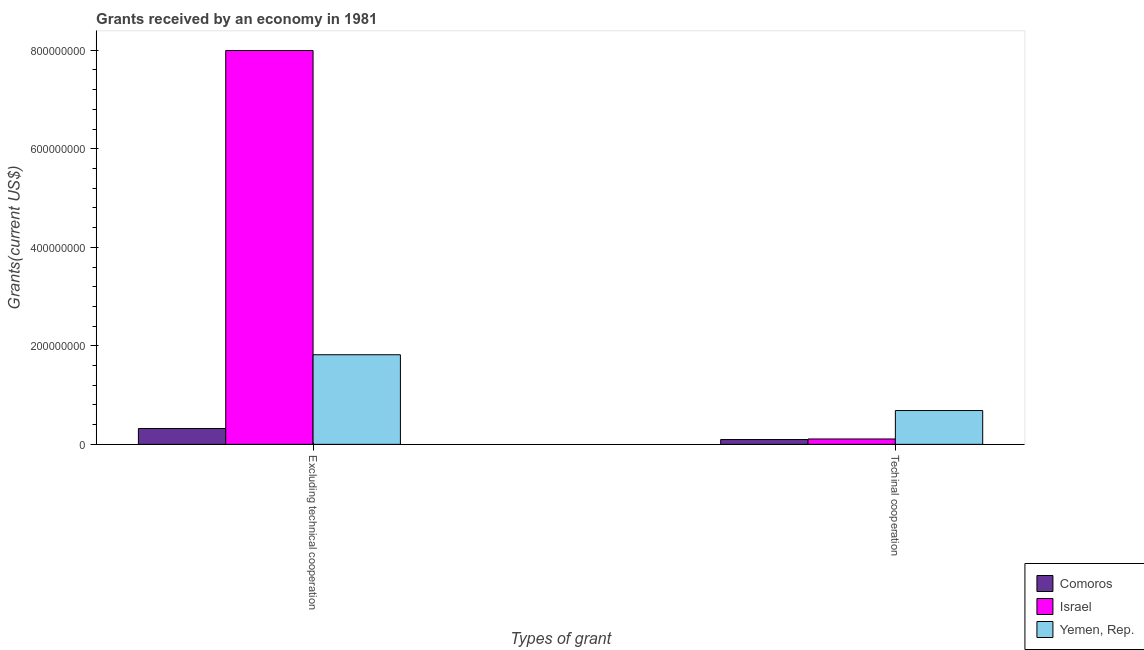How many different coloured bars are there?
Provide a succinct answer. 3. Are the number of bars on each tick of the X-axis equal?
Your answer should be very brief. Yes. How many bars are there on the 2nd tick from the left?
Provide a short and direct response. 3. What is the label of the 1st group of bars from the left?
Your answer should be very brief. Excluding technical cooperation. What is the amount of grants received(excluding technical cooperation) in Yemen, Rep.?
Offer a very short reply. 1.82e+08. Across all countries, what is the maximum amount of grants received(excluding technical cooperation)?
Give a very brief answer. 8.00e+08. Across all countries, what is the minimum amount of grants received(excluding technical cooperation)?
Provide a succinct answer. 3.21e+07. In which country was the amount of grants received(including technical cooperation) maximum?
Ensure brevity in your answer.  Yemen, Rep. In which country was the amount of grants received(excluding technical cooperation) minimum?
Ensure brevity in your answer.  Comoros. What is the total amount of grants received(including technical cooperation) in the graph?
Make the answer very short. 8.94e+07. What is the difference between the amount of grants received(excluding technical cooperation) in Comoros and that in Yemen, Rep.?
Your response must be concise. -1.50e+08. What is the difference between the amount of grants received(excluding technical cooperation) in Yemen, Rep. and the amount of grants received(including technical cooperation) in Comoros?
Provide a succinct answer. 1.72e+08. What is the average amount of grants received(including technical cooperation) per country?
Your answer should be very brief. 2.98e+07. What is the difference between the amount of grants received(including technical cooperation) and amount of grants received(excluding technical cooperation) in Israel?
Your answer should be compact. -7.89e+08. What is the ratio of the amount of grants received(excluding technical cooperation) in Yemen, Rep. to that in Israel?
Offer a very short reply. 0.23. In how many countries, is the amount of grants received(including technical cooperation) greater than the average amount of grants received(including technical cooperation) taken over all countries?
Give a very brief answer. 1. What does the 2nd bar from the left in Excluding technical cooperation represents?
Give a very brief answer. Israel. What does the 3rd bar from the right in Excluding technical cooperation represents?
Offer a terse response. Comoros. Are all the bars in the graph horizontal?
Ensure brevity in your answer.  No. How many countries are there in the graph?
Ensure brevity in your answer.  3. Does the graph contain any zero values?
Offer a terse response. No. Where does the legend appear in the graph?
Offer a terse response. Bottom right. How many legend labels are there?
Provide a short and direct response. 3. How are the legend labels stacked?
Your answer should be very brief. Vertical. What is the title of the graph?
Provide a short and direct response. Grants received by an economy in 1981. Does "Hong Kong" appear as one of the legend labels in the graph?
Your answer should be very brief. No. What is the label or title of the X-axis?
Your answer should be compact. Types of grant. What is the label or title of the Y-axis?
Ensure brevity in your answer.  Grants(current US$). What is the Grants(current US$) of Comoros in Excluding technical cooperation?
Provide a short and direct response. 3.21e+07. What is the Grants(current US$) of Israel in Excluding technical cooperation?
Offer a very short reply. 8.00e+08. What is the Grants(current US$) in Yemen, Rep. in Excluding technical cooperation?
Provide a succinct answer. 1.82e+08. What is the Grants(current US$) in Comoros in Techinal cooperation?
Provide a succinct answer. 9.79e+06. What is the Grants(current US$) in Israel in Techinal cooperation?
Your answer should be very brief. 1.09e+07. What is the Grants(current US$) of Yemen, Rep. in Techinal cooperation?
Ensure brevity in your answer.  6.86e+07. Across all Types of grant, what is the maximum Grants(current US$) of Comoros?
Provide a succinct answer. 3.21e+07. Across all Types of grant, what is the maximum Grants(current US$) in Israel?
Provide a short and direct response. 8.00e+08. Across all Types of grant, what is the maximum Grants(current US$) of Yemen, Rep.?
Provide a short and direct response. 1.82e+08. Across all Types of grant, what is the minimum Grants(current US$) of Comoros?
Your response must be concise. 9.79e+06. Across all Types of grant, what is the minimum Grants(current US$) in Israel?
Ensure brevity in your answer.  1.09e+07. Across all Types of grant, what is the minimum Grants(current US$) in Yemen, Rep.?
Offer a terse response. 6.86e+07. What is the total Grants(current US$) of Comoros in the graph?
Your answer should be very brief. 4.19e+07. What is the total Grants(current US$) in Israel in the graph?
Provide a succinct answer. 8.10e+08. What is the total Grants(current US$) in Yemen, Rep. in the graph?
Your response must be concise. 2.51e+08. What is the difference between the Grants(current US$) of Comoros in Excluding technical cooperation and that in Techinal cooperation?
Ensure brevity in your answer.  2.23e+07. What is the difference between the Grants(current US$) of Israel in Excluding technical cooperation and that in Techinal cooperation?
Your response must be concise. 7.89e+08. What is the difference between the Grants(current US$) in Yemen, Rep. in Excluding technical cooperation and that in Techinal cooperation?
Provide a short and direct response. 1.13e+08. What is the difference between the Grants(current US$) of Comoros in Excluding technical cooperation and the Grants(current US$) of Israel in Techinal cooperation?
Your answer should be compact. 2.12e+07. What is the difference between the Grants(current US$) of Comoros in Excluding technical cooperation and the Grants(current US$) of Yemen, Rep. in Techinal cooperation?
Keep it short and to the point. -3.65e+07. What is the difference between the Grants(current US$) of Israel in Excluding technical cooperation and the Grants(current US$) of Yemen, Rep. in Techinal cooperation?
Your answer should be compact. 7.31e+08. What is the average Grants(current US$) of Comoros per Types of grant?
Your answer should be compact. 2.10e+07. What is the average Grants(current US$) in Israel per Types of grant?
Provide a short and direct response. 4.05e+08. What is the average Grants(current US$) in Yemen, Rep. per Types of grant?
Ensure brevity in your answer.  1.25e+08. What is the difference between the Grants(current US$) in Comoros and Grants(current US$) in Israel in Excluding technical cooperation?
Provide a succinct answer. -7.67e+08. What is the difference between the Grants(current US$) in Comoros and Grants(current US$) in Yemen, Rep. in Excluding technical cooperation?
Ensure brevity in your answer.  -1.50e+08. What is the difference between the Grants(current US$) of Israel and Grants(current US$) of Yemen, Rep. in Excluding technical cooperation?
Offer a terse response. 6.18e+08. What is the difference between the Grants(current US$) in Comoros and Grants(current US$) in Israel in Techinal cooperation?
Give a very brief answer. -1.14e+06. What is the difference between the Grants(current US$) in Comoros and Grants(current US$) in Yemen, Rep. in Techinal cooperation?
Make the answer very short. -5.88e+07. What is the difference between the Grants(current US$) in Israel and Grants(current US$) in Yemen, Rep. in Techinal cooperation?
Keep it short and to the point. -5.77e+07. What is the ratio of the Grants(current US$) of Comoros in Excluding technical cooperation to that in Techinal cooperation?
Provide a short and direct response. 3.28. What is the ratio of the Grants(current US$) in Israel in Excluding technical cooperation to that in Techinal cooperation?
Offer a terse response. 73.15. What is the ratio of the Grants(current US$) of Yemen, Rep. in Excluding technical cooperation to that in Techinal cooperation?
Offer a terse response. 2.65. What is the difference between the highest and the second highest Grants(current US$) of Comoros?
Give a very brief answer. 2.23e+07. What is the difference between the highest and the second highest Grants(current US$) in Israel?
Make the answer very short. 7.89e+08. What is the difference between the highest and the second highest Grants(current US$) of Yemen, Rep.?
Offer a very short reply. 1.13e+08. What is the difference between the highest and the lowest Grants(current US$) in Comoros?
Provide a short and direct response. 2.23e+07. What is the difference between the highest and the lowest Grants(current US$) in Israel?
Offer a terse response. 7.89e+08. What is the difference between the highest and the lowest Grants(current US$) in Yemen, Rep.?
Your answer should be compact. 1.13e+08. 